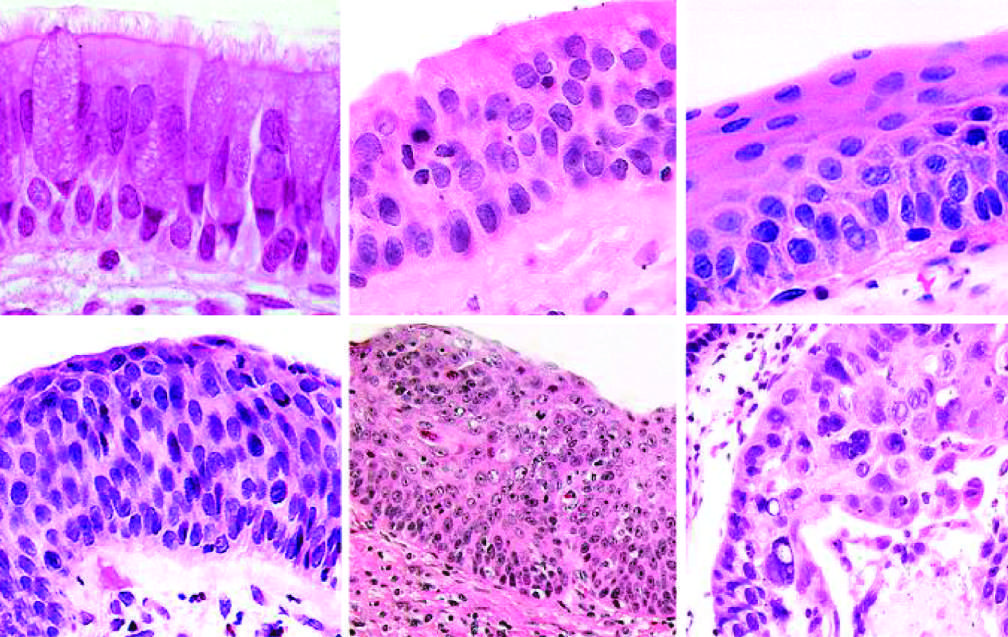what include the appearance of squamous dysplasia, characterized by the presence of disordered squamous epithelium, with loss of nuclear polarity, nuclear hyperchromasia, pleomorphism, and mitotic figures?
Answer the question using a single word or phrase. More ominous changes 